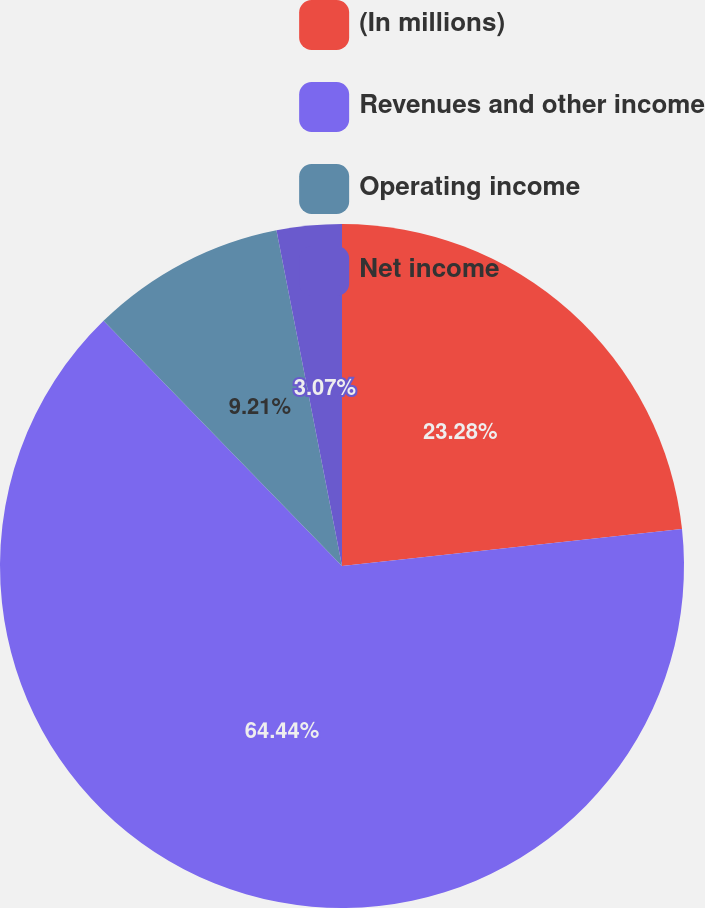Convert chart to OTSL. <chart><loc_0><loc_0><loc_500><loc_500><pie_chart><fcel>(In millions)<fcel>Revenues and other income<fcel>Operating income<fcel>Net income<nl><fcel>23.28%<fcel>64.44%<fcel>9.21%<fcel>3.07%<nl></chart> 